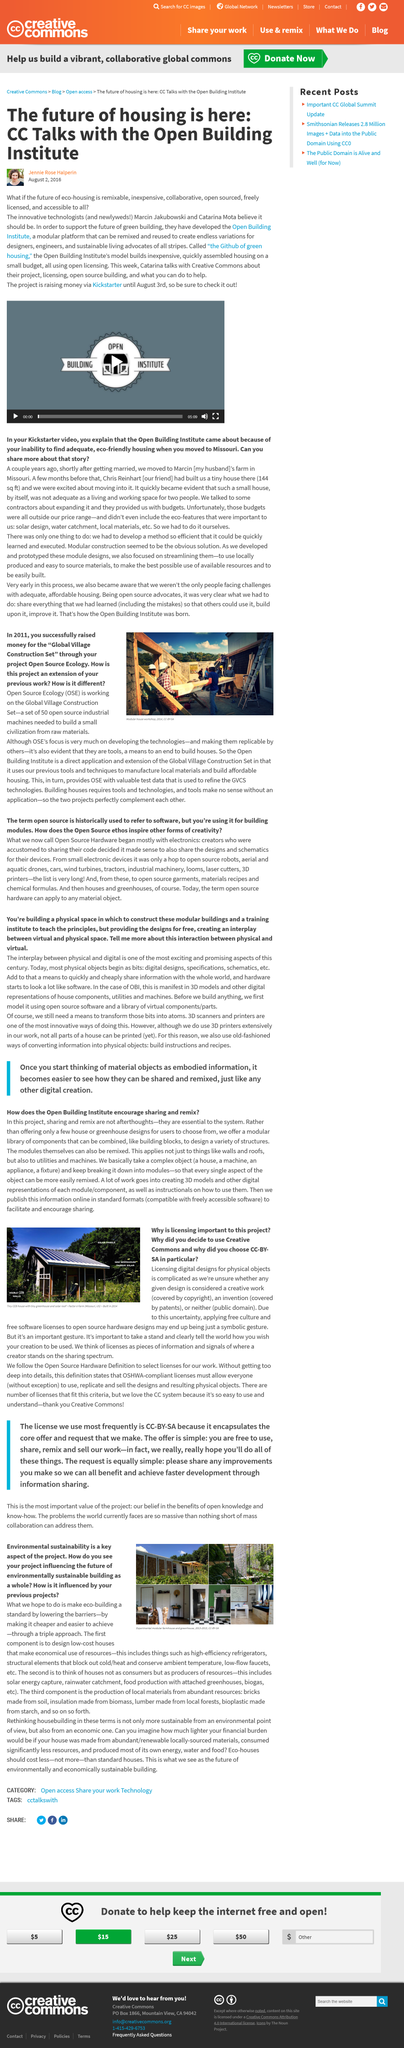List a handful of essential elements in this visual. The Open Building Institute is remixable, inexpensive, collaborative, open-sourced, freely licensed, and accessible to all, making it a powerful resource for promoting sustainable building practices and advancing the field of construction engineering. The Open Building Institute is a modular platform that enables designers, engineers, and sustainable living advocates to create endless variations through remixing and reusing its components. The project is expected to raise money until August 3rd. 